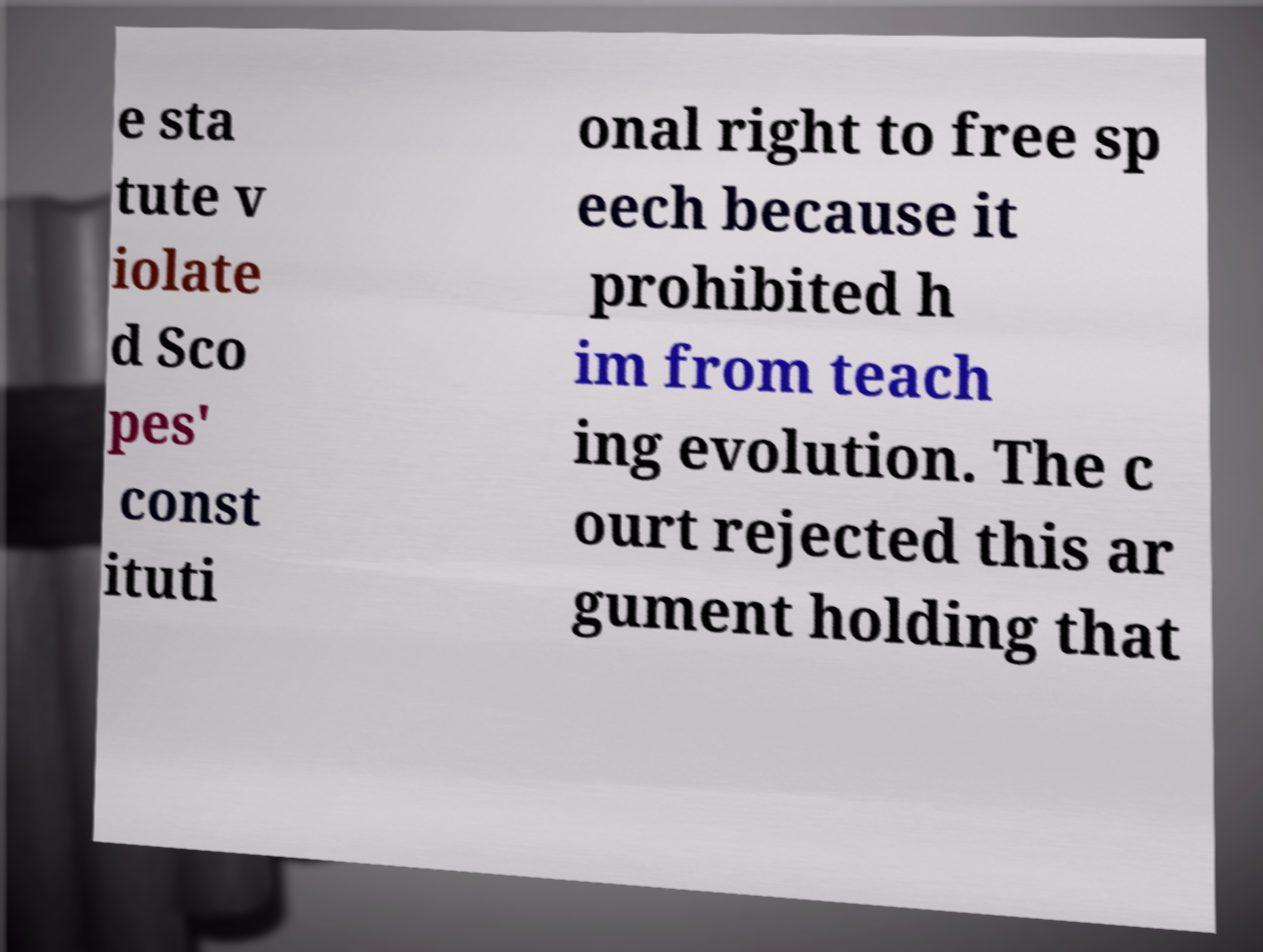Could you extract and type out the text from this image? e sta tute v iolate d Sco pes' const ituti onal right to free sp eech because it prohibited h im from teach ing evolution. The c ourt rejected this ar gument holding that 